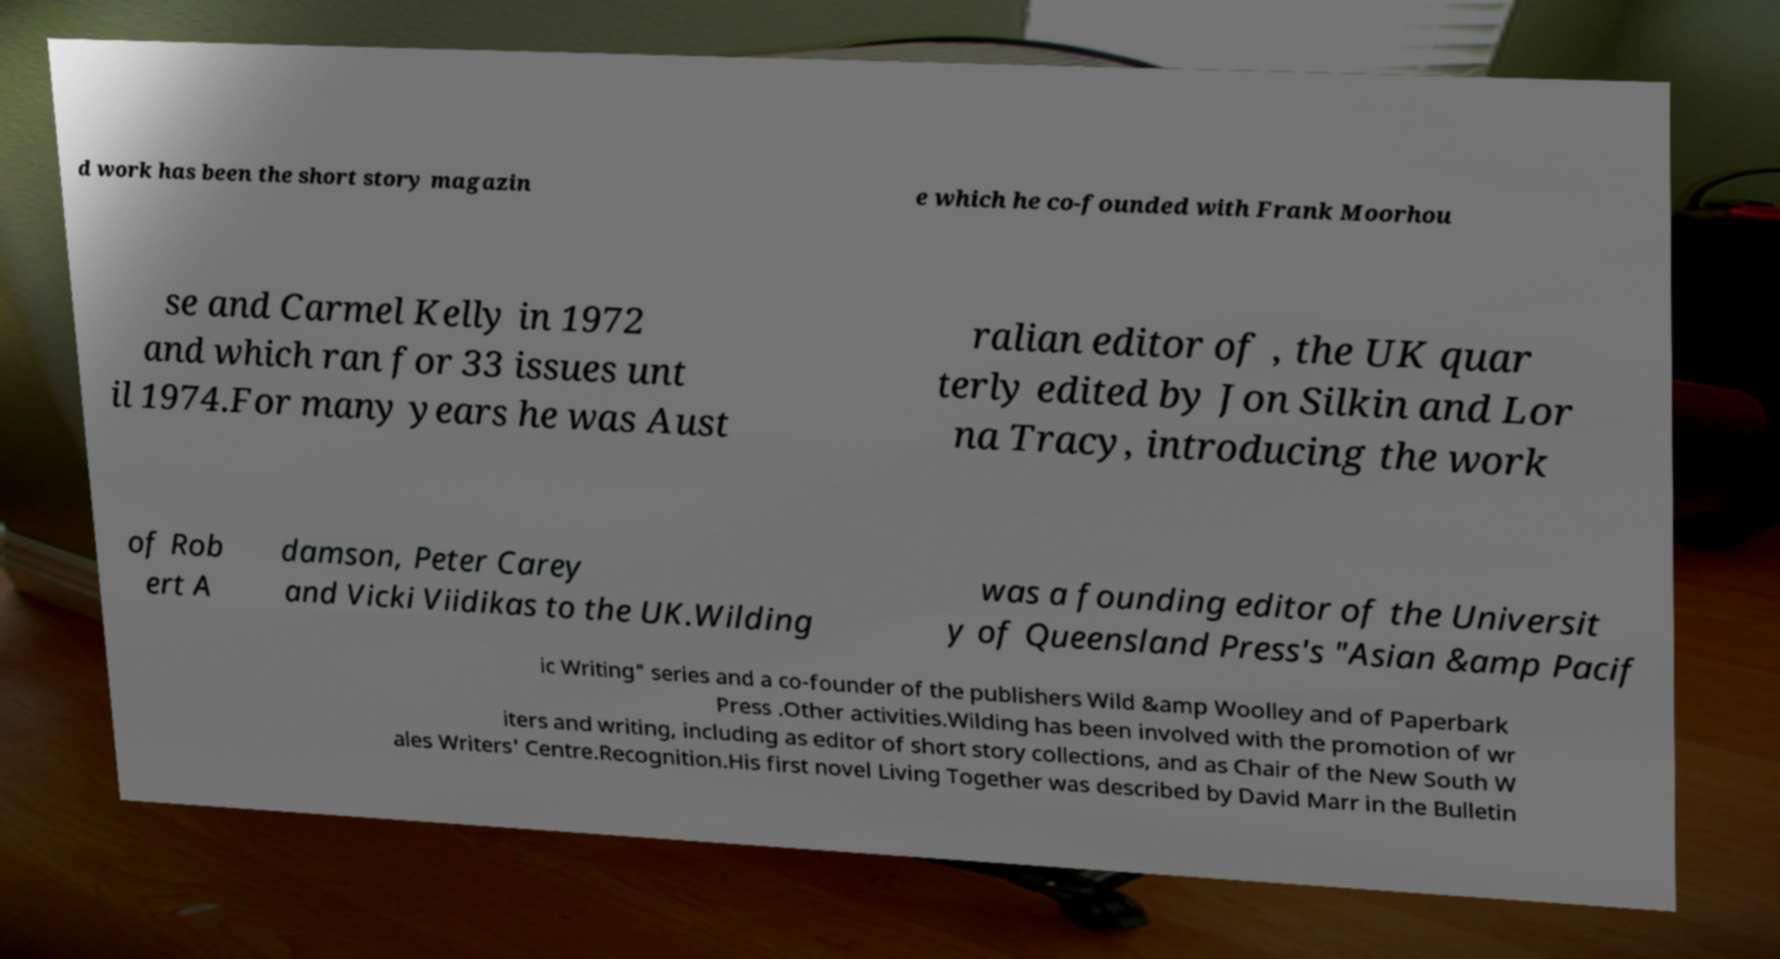Please identify and transcribe the text found in this image. d work has been the short story magazin e which he co-founded with Frank Moorhou se and Carmel Kelly in 1972 and which ran for 33 issues unt il 1974.For many years he was Aust ralian editor of , the UK quar terly edited by Jon Silkin and Lor na Tracy, introducing the work of Rob ert A damson, Peter Carey and Vicki Viidikas to the UK.Wilding was a founding editor of the Universit y of Queensland Press's "Asian &amp Pacif ic Writing" series and a co-founder of the publishers Wild &amp Woolley and of Paperbark Press .Other activities.Wilding has been involved with the promotion of wr iters and writing, including as editor of short story collections, and as Chair of the New South W ales Writers' Centre.Recognition.His first novel Living Together was described by David Marr in the Bulletin 